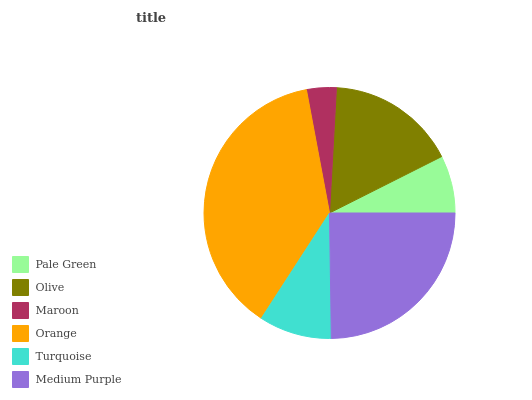Is Maroon the minimum?
Answer yes or no. Yes. Is Orange the maximum?
Answer yes or no. Yes. Is Olive the minimum?
Answer yes or no. No. Is Olive the maximum?
Answer yes or no. No. Is Olive greater than Pale Green?
Answer yes or no. Yes. Is Pale Green less than Olive?
Answer yes or no. Yes. Is Pale Green greater than Olive?
Answer yes or no. No. Is Olive less than Pale Green?
Answer yes or no. No. Is Olive the high median?
Answer yes or no. Yes. Is Turquoise the low median?
Answer yes or no. Yes. Is Medium Purple the high median?
Answer yes or no. No. Is Olive the low median?
Answer yes or no. No. 